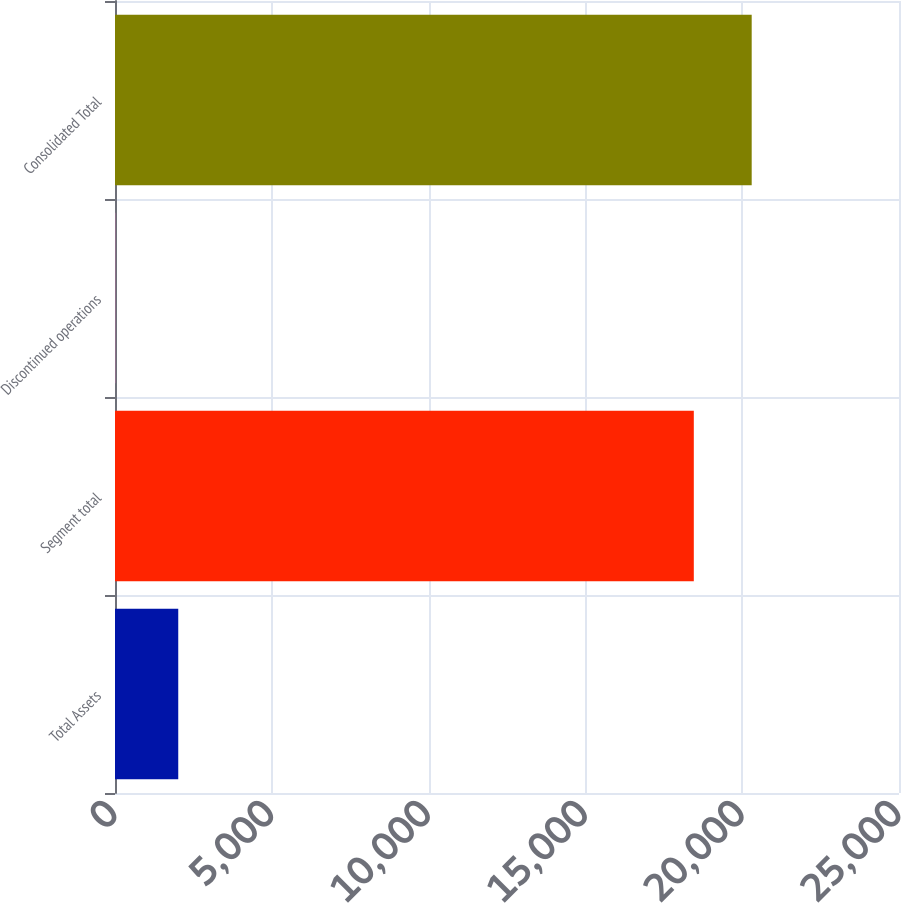Convert chart to OTSL. <chart><loc_0><loc_0><loc_500><loc_500><bar_chart><fcel>Total Assets<fcel>Segment total<fcel>Discontinued operations<fcel>Consolidated Total<nl><fcel>2017<fcel>18457<fcel>10.2<fcel>20302.7<nl></chart> 